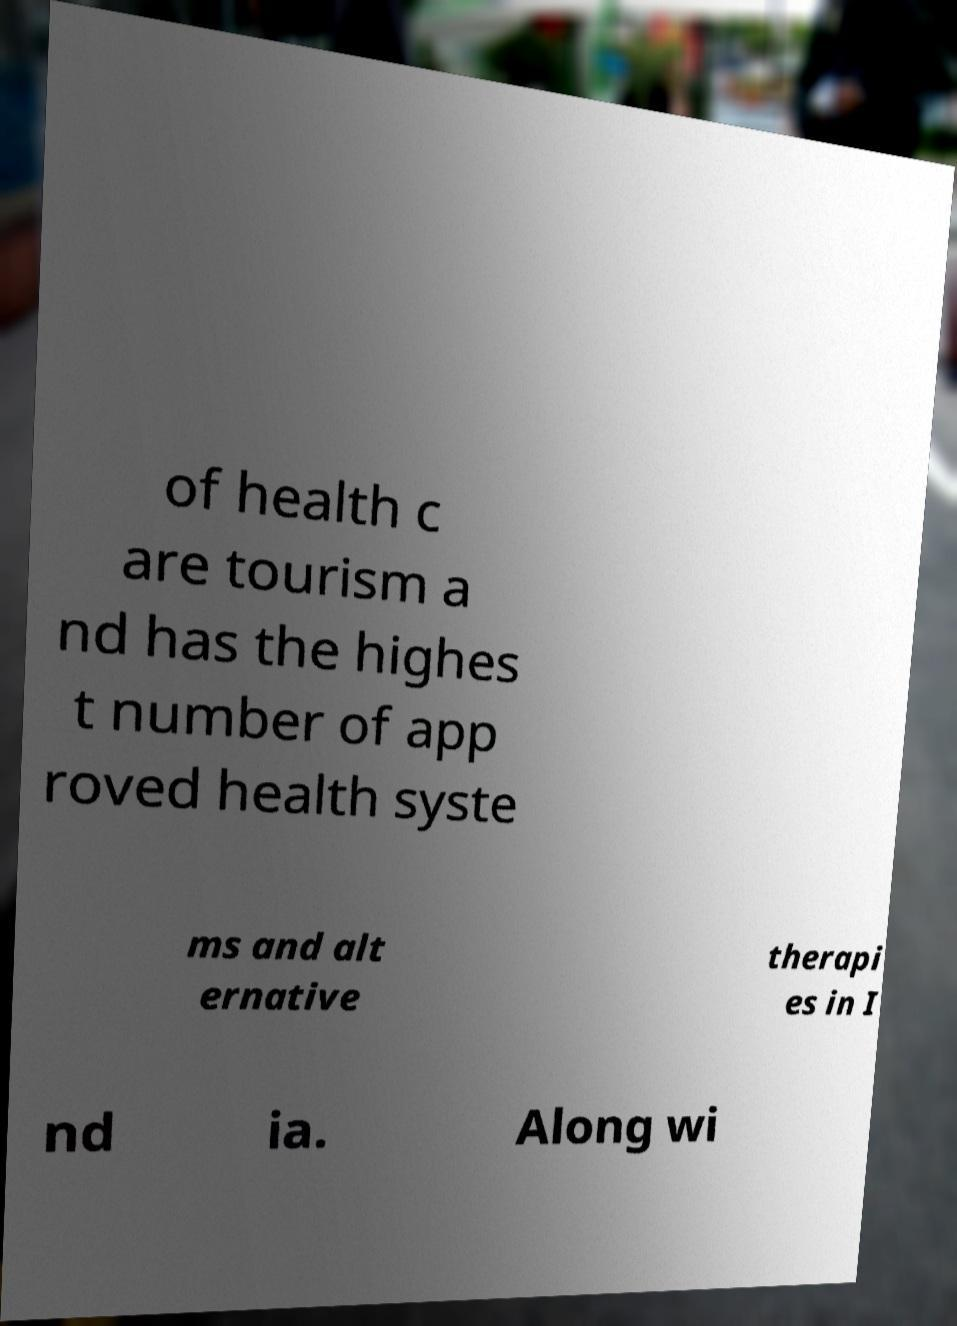Could you assist in decoding the text presented in this image and type it out clearly? of health c are tourism a nd has the highes t number of app roved health syste ms and alt ernative therapi es in I nd ia. Along wi 